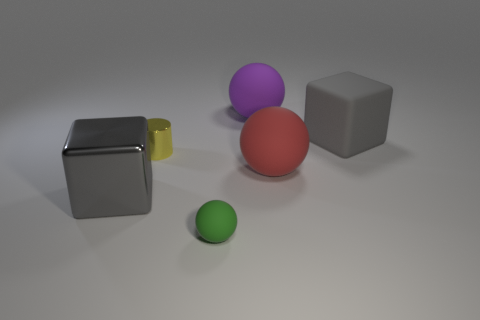Subtract all large purple spheres. How many spheres are left? 2 Subtract all red balls. How many balls are left? 2 Subtract 1 cylinders. How many cylinders are left? 0 Add 2 purple spheres. How many objects exist? 8 Subtract all blocks. How many objects are left? 4 Add 4 tiny things. How many tiny things are left? 6 Add 6 big gray cylinders. How many big gray cylinders exist? 6 Subtract 0 purple cylinders. How many objects are left? 6 Subtract all green spheres. Subtract all blue cylinders. How many spheres are left? 2 Subtract all yellow cubes. How many brown cylinders are left? 0 